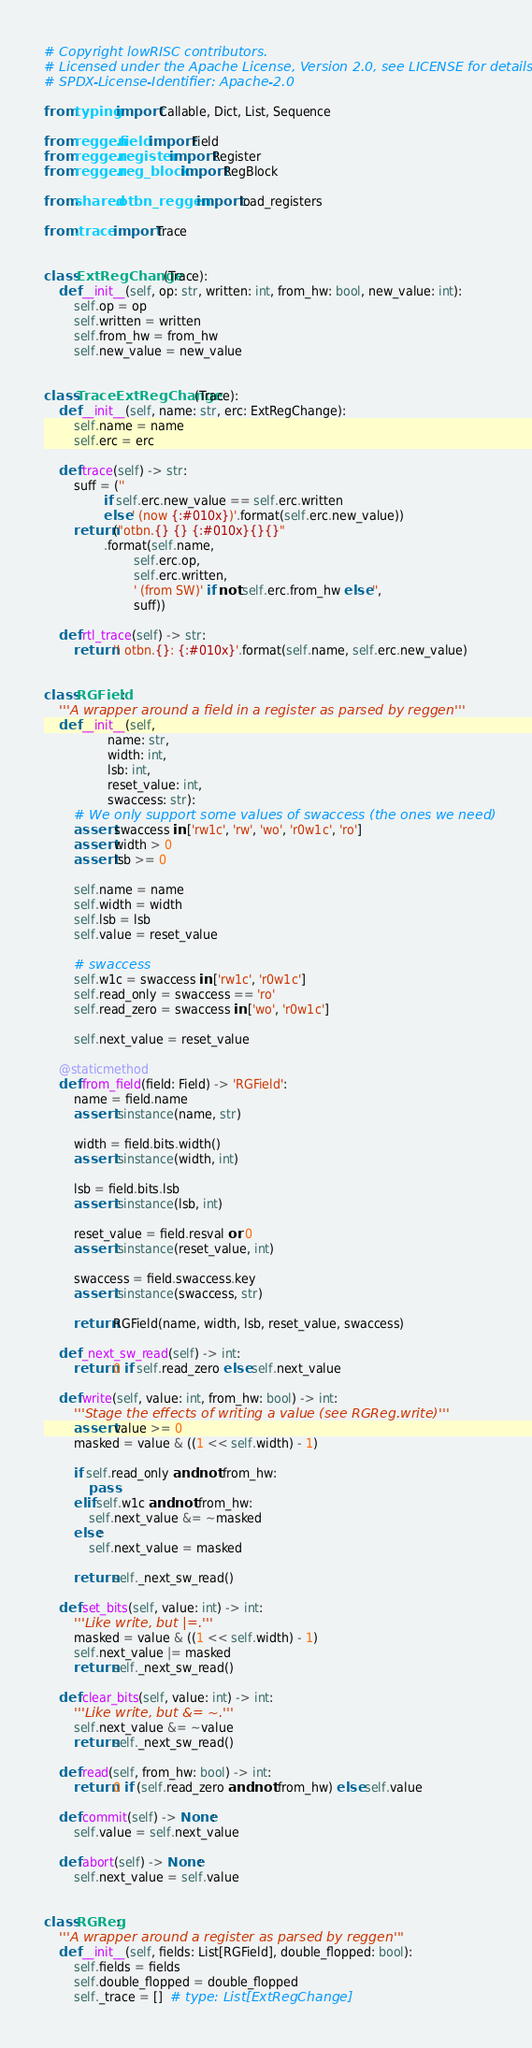Convert code to text. <code><loc_0><loc_0><loc_500><loc_500><_Python_># Copyright lowRISC contributors.
# Licensed under the Apache License, Version 2.0, see LICENSE for details.
# SPDX-License-Identifier: Apache-2.0

from typing import Callable, Dict, List, Sequence

from reggen.field import Field
from reggen.register import Register
from reggen.reg_block import RegBlock

from shared.otbn_reggen import load_registers

from .trace import Trace


class ExtRegChange(Trace):
    def __init__(self, op: str, written: int, from_hw: bool, new_value: int):
        self.op = op
        self.written = written
        self.from_hw = from_hw
        self.new_value = new_value


class TraceExtRegChange(Trace):
    def __init__(self, name: str, erc: ExtRegChange):
        self.name = name
        self.erc = erc

    def trace(self) -> str:
        suff = (''
                if self.erc.new_value == self.erc.written
                else ' (now {:#010x})'.format(self.erc.new_value))
        return ("otbn.{} {} {:#010x}{}{}"
                .format(self.name,
                        self.erc.op,
                        self.erc.written,
                        ' (from SW)' if not self.erc.from_hw else '',
                        suff))

    def rtl_trace(self) -> str:
        return '! otbn.{}: {:#010x}'.format(self.name, self.erc.new_value)


class RGField:
    '''A wrapper around a field in a register as parsed by reggen'''
    def __init__(self,
                 name: str,
                 width: int,
                 lsb: int,
                 reset_value: int,
                 swaccess: str):
        # We only support some values of swaccess (the ones we need)
        assert swaccess in ['rw1c', 'rw', 'wo', 'r0w1c', 'ro']
        assert width > 0
        assert lsb >= 0

        self.name = name
        self.width = width
        self.lsb = lsb
        self.value = reset_value

        # swaccess
        self.w1c = swaccess in ['rw1c', 'r0w1c']
        self.read_only = swaccess == 'ro'
        self.read_zero = swaccess in ['wo', 'r0w1c']

        self.next_value = reset_value

    @staticmethod
    def from_field(field: Field) -> 'RGField':
        name = field.name
        assert isinstance(name, str)

        width = field.bits.width()
        assert isinstance(width, int)

        lsb = field.bits.lsb
        assert isinstance(lsb, int)

        reset_value = field.resval or 0
        assert isinstance(reset_value, int)

        swaccess = field.swaccess.key
        assert isinstance(swaccess, str)

        return RGField(name, width, lsb, reset_value, swaccess)

    def _next_sw_read(self) -> int:
        return 0 if self.read_zero else self.next_value

    def write(self, value: int, from_hw: bool) -> int:
        '''Stage the effects of writing a value (see RGReg.write)'''
        assert value >= 0
        masked = value & ((1 << self.width) - 1)

        if self.read_only and not from_hw:
            pass
        elif self.w1c and not from_hw:
            self.next_value &= ~masked
        else:
            self.next_value = masked

        return self._next_sw_read()

    def set_bits(self, value: int) -> int:
        '''Like write, but |=.'''
        masked = value & ((1 << self.width) - 1)
        self.next_value |= masked
        return self._next_sw_read()

    def clear_bits(self, value: int) -> int:
        '''Like write, but &= ~.'''
        self.next_value &= ~value
        return self._next_sw_read()

    def read(self, from_hw: bool) -> int:
        return 0 if (self.read_zero and not from_hw) else self.value

    def commit(self) -> None:
        self.value = self.next_value

    def abort(self) -> None:
        self.next_value = self.value


class RGReg:
    '''A wrapper around a register as parsed by reggen'''
    def __init__(self, fields: List[RGField], double_flopped: bool):
        self.fields = fields
        self.double_flopped = double_flopped
        self._trace = []  # type: List[ExtRegChange]</code> 